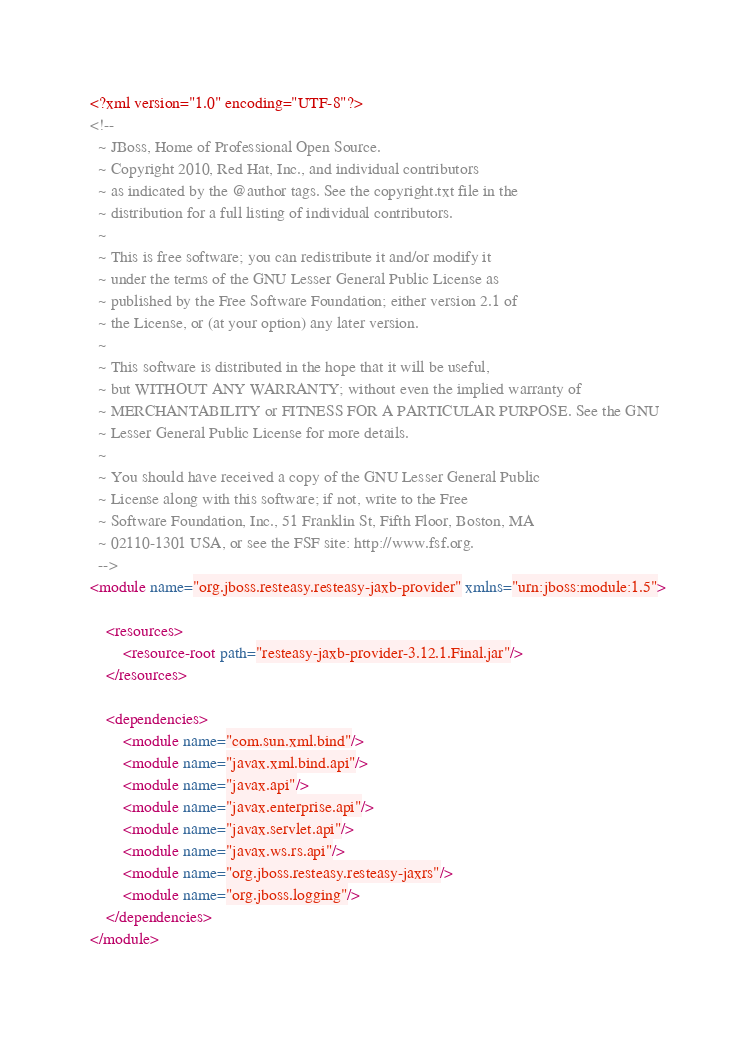<code> <loc_0><loc_0><loc_500><loc_500><_XML_><?xml version="1.0" encoding="UTF-8"?>
<!--
  ~ JBoss, Home of Professional Open Source.
  ~ Copyright 2010, Red Hat, Inc., and individual contributors
  ~ as indicated by the @author tags. See the copyright.txt file in the
  ~ distribution for a full listing of individual contributors.
  ~
  ~ This is free software; you can redistribute it and/or modify it
  ~ under the terms of the GNU Lesser General Public License as
  ~ published by the Free Software Foundation; either version 2.1 of
  ~ the License, or (at your option) any later version.
  ~
  ~ This software is distributed in the hope that it will be useful,
  ~ but WITHOUT ANY WARRANTY; without even the implied warranty of
  ~ MERCHANTABILITY or FITNESS FOR A PARTICULAR PURPOSE. See the GNU
  ~ Lesser General Public License for more details.
  ~
  ~ You should have received a copy of the GNU Lesser General Public
  ~ License along with this software; if not, write to the Free
  ~ Software Foundation, Inc., 51 Franklin St, Fifth Floor, Boston, MA
  ~ 02110-1301 USA, or see the FSF site: http://www.fsf.org.
  -->
<module name="org.jboss.resteasy.resteasy-jaxb-provider" xmlns="urn:jboss:module:1.5">

    <resources>
        <resource-root path="resteasy-jaxb-provider-3.12.1.Final.jar"/>
    </resources>

    <dependencies>
        <module name="com.sun.xml.bind"/>
        <module name="javax.xml.bind.api"/>
        <module name="javax.api"/>
        <module name="javax.enterprise.api"/>
        <module name="javax.servlet.api"/>
        <module name="javax.ws.rs.api"/>
        <module name="org.jboss.resteasy.resteasy-jaxrs"/>
        <module name="org.jboss.logging"/>
    </dependencies>
</module>
</code> 